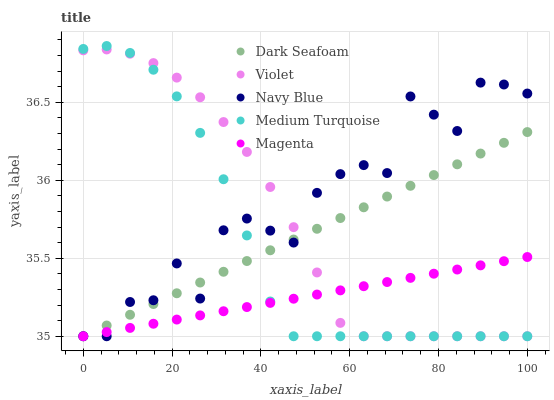Does Magenta have the minimum area under the curve?
Answer yes or no. Yes. Does Navy Blue have the maximum area under the curve?
Answer yes or no. Yes. Does Dark Seafoam have the minimum area under the curve?
Answer yes or no. No. Does Dark Seafoam have the maximum area under the curve?
Answer yes or no. No. Is Magenta the smoothest?
Answer yes or no. Yes. Is Navy Blue the roughest?
Answer yes or no. Yes. Is Dark Seafoam the smoothest?
Answer yes or no. No. Is Dark Seafoam the roughest?
Answer yes or no. No. Does Navy Blue have the lowest value?
Answer yes or no. Yes. Does Medium Turquoise have the highest value?
Answer yes or no. Yes. Does Dark Seafoam have the highest value?
Answer yes or no. No. Does Navy Blue intersect Magenta?
Answer yes or no. Yes. Is Navy Blue less than Magenta?
Answer yes or no. No. Is Navy Blue greater than Magenta?
Answer yes or no. No. 